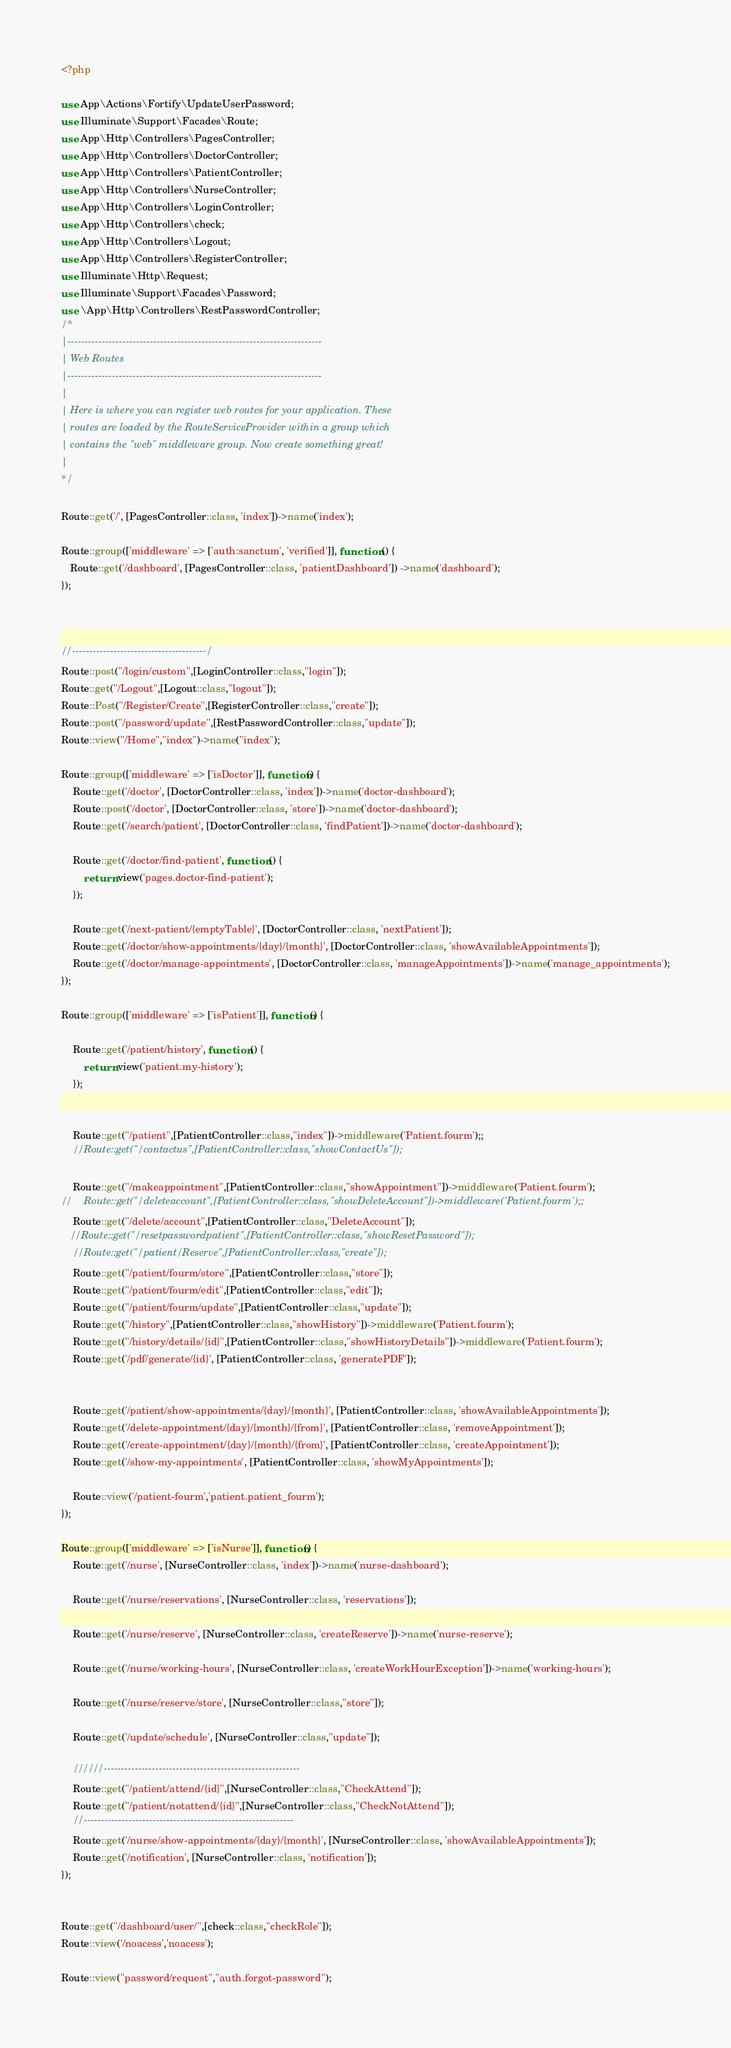Convert code to text. <code><loc_0><loc_0><loc_500><loc_500><_PHP_><?php

use App\Actions\Fortify\UpdateUserPassword;
use Illuminate\Support\Facades\Route;
use App\Http\Controllers\PagesController;
use App\Http\Controllers\DoctorController;
use App\Http\Controllers\PatientController;
use App\Http\Controllers\NurseController;
use App\Http\Controllers\LoginController;
use App\Http\Controllers\check;
use App\Http\Controllers\Logout;
use App\Http\Controllers\RegisterController;
use Illuminate\Http\Request;
use Illuminate\Support\Facades\Password;
use \App\Http\Controllers\RestPasswordController;
/*
|--------------------------------------------------------------------------
| Web Routes
|--------------------------------------------------------------------------
|
| Here is where you can register web routes for your application. These
| routes are loaded by the RouteServiceProvider within a group which
| contains the "web" middleware group. Now create something great!
|
*/

Route::get('/', [PagesController::class, 'index'])->name('index');

Route::group(['middleware' => ['auth:sanctum', 'verified']], function () {
   Route::get('/dashboard', [PagesController::class, 'patientDashboard']) ->name('dashboard');
});



//---------------------------------------/
Route::post("/login/custom",[LoginController::class,"login"]);
Route::get("/Logout",[Logout::class,"logout"]);
Route::Post("/Register/Create",[RegisterController::class,"create"]);
Route::post("/password/update",[RestPasswordController::class,"update"]);
Route::view("/Home","index")->name("index");

Route::group(['middleware' => ['isDoctor']], function() {
    Route::get('/doctor', [DoctorController::class, 'index'])->name('doctor-dashboard');
    Route::post('/doctor', [DoctorController::class, 'store'])->name('doctor-dashboard');
    Route::get('/search/patient', [DoctorController::class, 'findPatient'])->name('doctor-dashboard');

    Route::get('/doctor/find-patient', function () {
        return view('pages.doctor-find-patient');
    });

    Route::get('/next-patient/{emptyTable}', [DoctorController::class, 'nextPatient']);
    Route::get('/doctor/show-appointments/{day}/{month}', [DoctorController::class, 'showAvailableAppointments']);
    Route::get('/doctor/manage-appointments', [DoctorController::class, 'manageAppointments'])->name('manage_appointments');
});

Route::group(['middleware' => ['isPatient']], function() {

    Route::get('/patient/history', function () {
        return view('patient.my-history');
    });


    Route::get("/patient",[PatientController::class,"index"])->middleware('Patient.fourm');;
    //Route::get("/contactus",[PatientController::class,"showContactUs"]);

    Route::get("/makeappointment",[PatientController::class,"showAppointment"])->middleware('Patient.fourm');
//    Route::get("/deleteaccount",[PatientController::class,"showDeleteAccount"])->middleware('Patient.fourm');;
    Route::get("/delete/account",[PatientController::class,"DeleteAccount"]);
   //Route::get("/resetpasswordpatient",[PatientController::class,"showResetPassword"]);
    //Route::get("/patient/Reserve",[PatientController::class,"create"]);
    Route::get("/patient/fourm/store",[PatientController::class,"store"]);
    Route::get("/patient/fourm/edit",[PatientController::class,"edit"]);
    Route::get("/patient/fourm/update",[PatientController::class,"update"]);
    Route::get("/history",[PatientController::class,"showHistory"])->middleware('Patient.fourm');
    Route::get("/history/details/{id}",[PatientController::class,"showHistoryDetails"])->middleware('Patient.fourm');
    Route::get('/pdf/generate/{id}', [PatientController::class, 'generatePDF']);


    Route::get('/patient/show-appointments/{day}/{month}', [PatientController::class, 'showAvailableAppointments']);
    Route::get('/delete-appointment/{day}/{month}/{from}', [PatientController::class, 'removeAppointment']);
    Route::get('/create-appointment/{day}/{month}/{from}', [PatientController::class, 'createAppointment']);
    Route::get('/show-my-appointments', [PatientController::class, 'showMyAppointments']);

    Route::view('/patient-fourm','patient.patient_fourm');
});

Route::group(['middleware' => ['isNurse']], function() {
    Route::get('/nurse', [NurseController::class, 'index'])->name('nurse-dashboard');

    Route::get('/nurse/reservations', [NurseController::class, 'reservations']);

    Route::get('/nurse/reserve', [NurseController::class, 'createReserve'])->name('nurse-reserve');

    Route::get('/nurse/working-hours', [NurseController::class, 'createWorkHourException'])->name('working-hours');

    Route::get('/nurse/reserve/store', [NurseController::class,"store"]);

    Route::get('/update/schedule', [NurseController::class,"update"]);

    //////---------------------------------------------------------
    Route::get("/patient/attend/{id}",[NurseController::class,"CheckAttend"]);
    Route::get("/patient/notattend/{id}",[NurseController::class,"CheckNotAttend"]);
    //-------------------------------------------------------------
    Route::get('/nurse/show-appointments/{day}/{month}', [NurseController::class, 'showAvailableAppointments']);
    Route::get('/notification', [NurseController::class, 'notification']);
});


Route::get("/dashboard/user/",[check::class,"checkRole"]);
Route::view('/noacess','noacess');

Route::view("password/request","auth.forgot-password");
</code> 